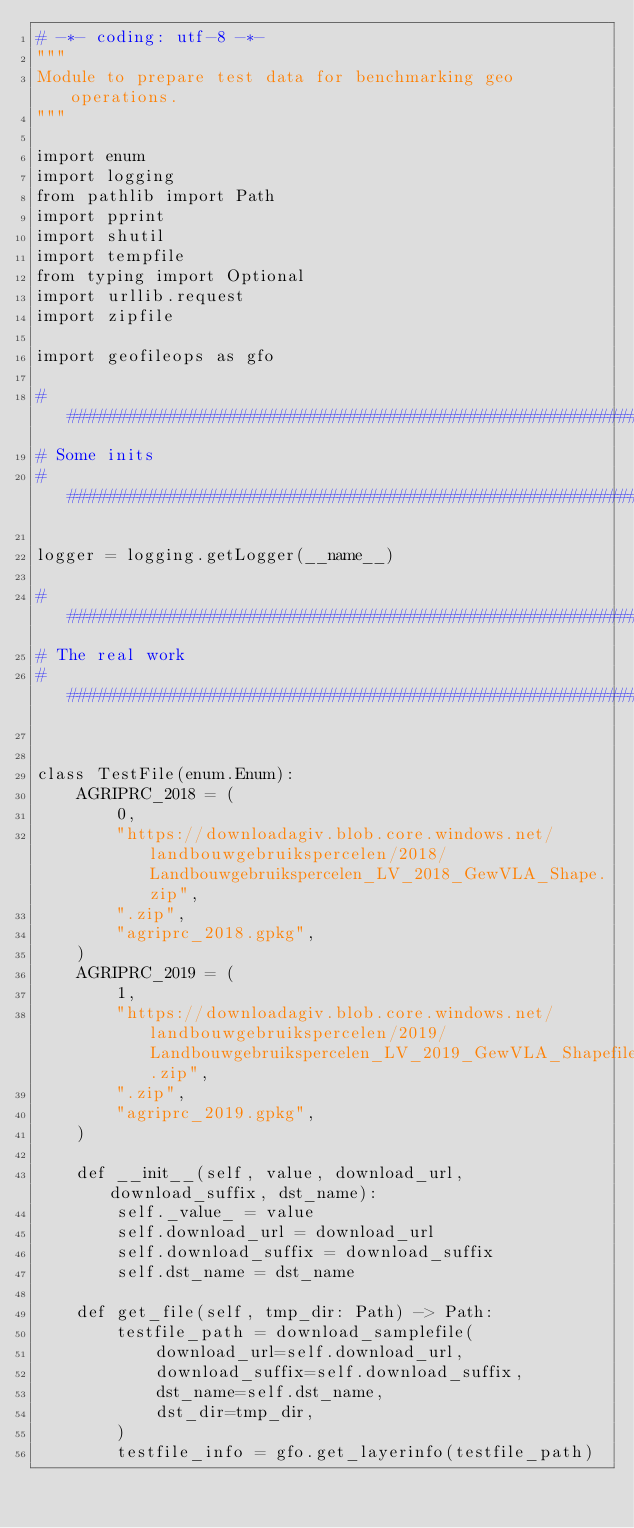Convert code to text. <code><loc_0><loc_0><loc_500><loc_500><_Python_># -*- coding: utf-8 -*-
"""
Module to prepare test data for benchmarking geo operations.
"""

import enum
import logging
from pathlib import Path
import pprint
import shutil
import tempfile
from typing import Optional
import urllib.request
import zipfile

import geofileops as gfo

################################################################################
# Some inits
################################################################################

logger = logging.getLogger(__name__)

################################################################################
# The real work
################################################################################


class TestFile(enum.Enum):
    AGRIPRC_2018 = (
        0,
        "https://downloadagiv.blob.core.windows.net/landbouwgebruikspercelen/2018/Landbouwgebruikspercelen_LV_2018_GewVLA_Shape.zip",
        ".zip",
        "agriprc_2018.gpkg",
    )
    AGRIPRC_2019 = (
        1,
        "https://downloadagiv.blob.core.windows.net/landbouwgebruikspercelen/2019/Landbouwgebruikspercelen_LV_2019_GewVLA_Shapefile.zip",
        ".zip",
        "agriprc_2019.gpkg",
    )

    def __init__(self, value, download_url, download_suffix, dst_name):
        self._value_ = value
        self.download_url = download_url
        self.download_suffix = download_suffix
        self.dst_name = dst_name

    def get_file(self, tmp_dir: Path) -> Path:
        testfile_path = download_samplefile(
            download_url=self.download_url,
            download_suffix=self.download_suffix,
            dst_name=self.dst_name,
            dst_dir=tmp_dir,
        )
        testfile_info = gfo.get_layerinfo(testfile_path)</code> 